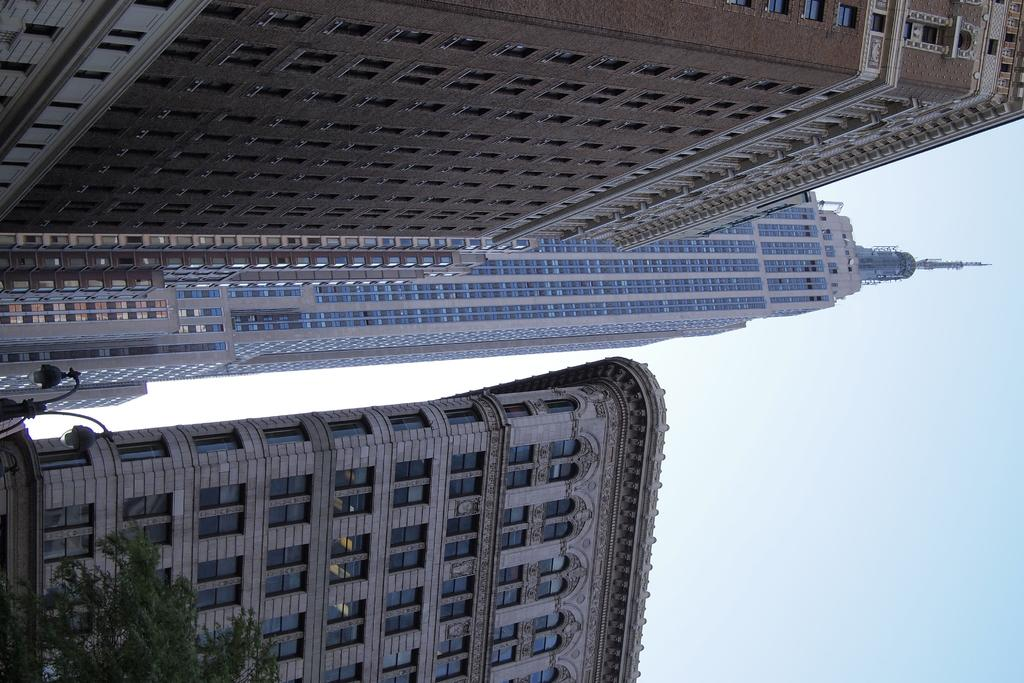What type of natural element is present in the image? There is a tree in the image. What artificial element can be seen in the image? There is a street light in the image. What type of structures are visible in the background of the image? There are buildings in the background of the image. What part of the natural environment is visible in the image? The sky is visible in the background of the image. Can you see a chain hanging from the tree in the image? There is no chain hanging from the tree in the image. What type of tin object is present in the image? There is no tin object present in the image. 